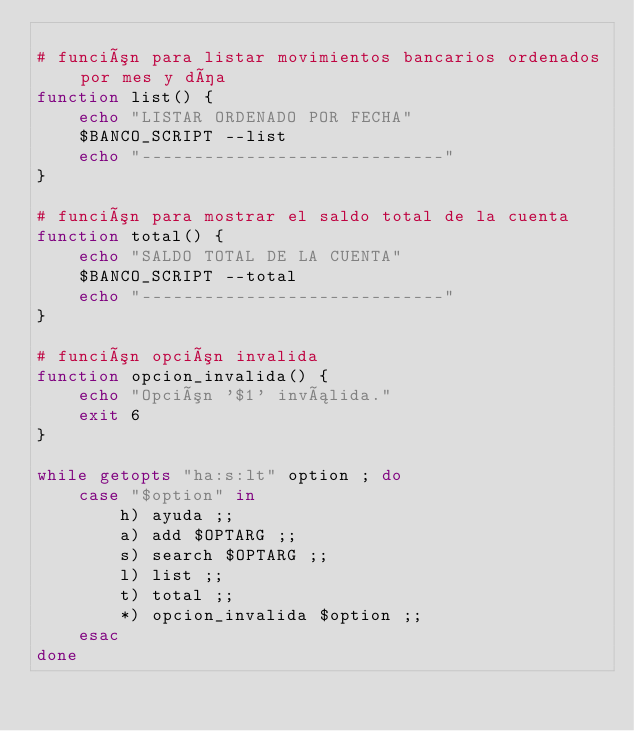<code> <loc_0><loc_0><loc_500><loc_500><_Bash_>
# función para listar movimientos bancarios ordenados por mes y día
function list() {
    echo "LISTAR ORDENADO POR FECHA"
    $BANCO_SCRIPT --list
    echo "-----------------------------"
}

# función para mostrar el saldo total de la cuenta
function total() {
    echo "SALDO TOTAL DE LA CUENTA"
    $BANCO_SCRIPT --total
    echo "-----------------------------"
}

# función opción invalida
function opcion_invalida() {
    echo "Opción '$1' inválida."
    exit 6
}

while getopts "ha:s:lt" option ; do 
    case "$option" in 
        h) ayuda ;;
        a) add $OPTARG ;;
        s) search $OPTARG ;;
        l) list ;;
        t) total ;;
        *) opcion_invalida $option ;;
    esac
done
</code> 